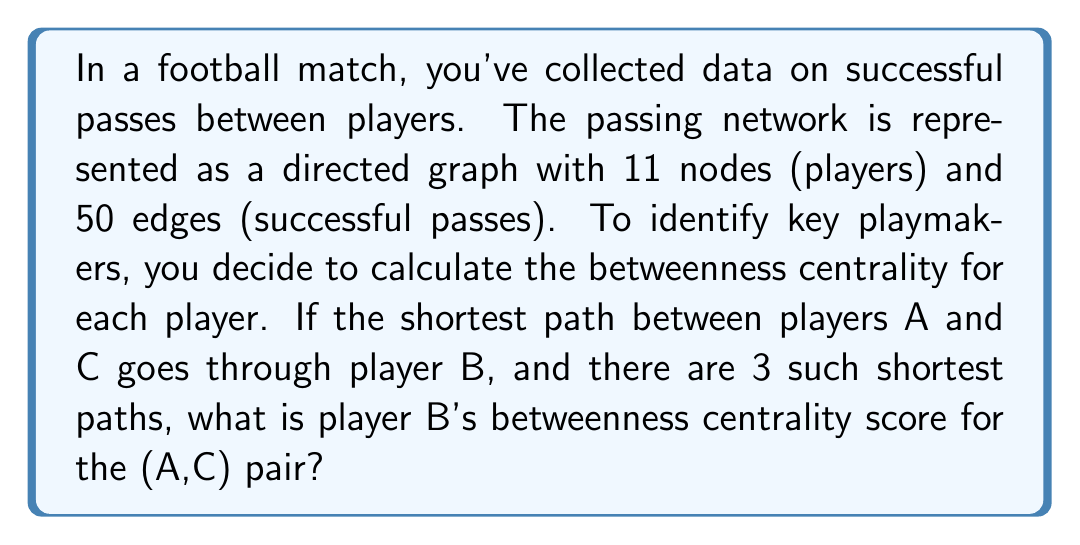Provide a solution to this math problem. To solve this problem, we need to understand the concept of betweenness centrality in graph theory and how it applies to football passing networks.

1. Betweenness centrality is a measure of a node's importance based on how often it lies on the shortest paths between other nodes.

2. The formula for betweenness centrality of a node $v$ is:

   $$BC(v) = \sum_{s \neq v \neq t} \frac{\sigma_{st}(v)}{\sigma_{st}}$$

   Where:
   - $\sigma_{st}$ is the total number of shortest paths from node $s$ to node $t$
   - $\sigma_{st}(v)$ is the number of those paths that pass through $v$

3. In this case, we're focusing on a single pair of players (A,C) and player B who lies on the shortest path between them.

4. We're given that:
   - There are 3 shortest paths between A and C
   - All of these paths go through B

5. Therefore:
   - $\sigma_{AC} = 3$ (total number of shortest paths from A to C)
   - $\sigma_{AC}(B) = 3$ (number of shortest paths from A to C that pass through B)

6. Applying the formula for this specific pair:

   $$BC_B(A,C) = \frac{\sigma_{AC}(B)}{\sigma_{AC}} = \frac{3}{3} = 1$$

This means that for the (A,C) pair, player B's betweenness centrality score is 1.

Note: To get the total betweenness centrality for player B, you would need to sum this value over all pairs of players in the network. This partial score of 1 for a single pair indicates that player B is crucial for connecting players A and C in the passing network.
Answer: Player B's betweenness centrality score for the (A,C) pair is 1. 